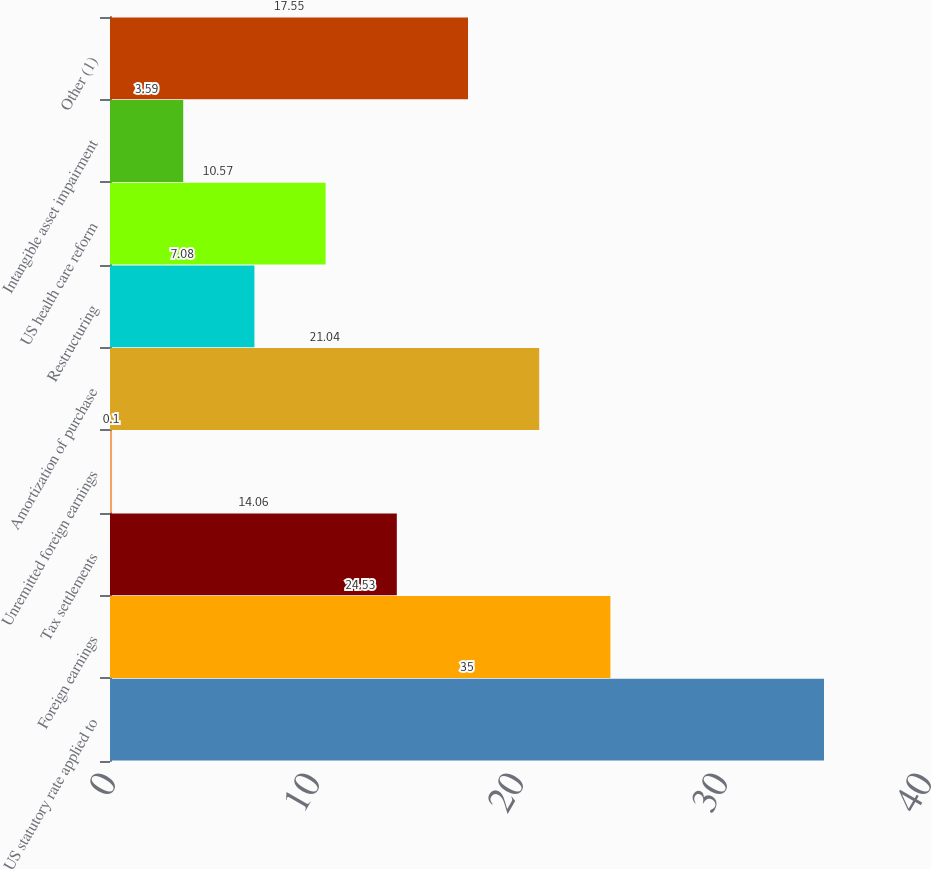Convert chart. <chart><loc_0><loc_0><loc_500><loc_500><bar_chart><fcel>US statutory rate applied to<fcel>Foreign earnings<fcel>Tax settlements<fcel>Unremitted foreign earnings<fcel>Amortization of purchase<fcel>Restructuring<fcel>US health care reform<fcel>Intangible asset impairment<fcel>Other (1)<nl><fcel>35<fcel>24.53<fcel>14.06<fcel>0.1<fcel>21.04<fcel>7.08<fcel>10.57<fcel>3.59<fcel>17.55<nl></chart> 